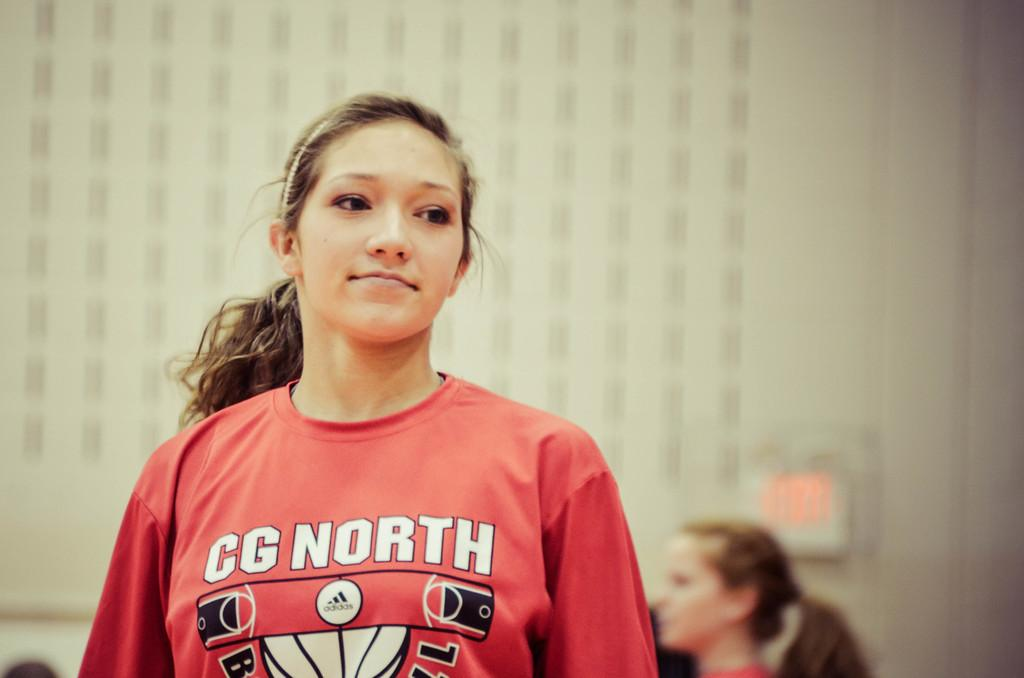<image>
Give a short and clear explanation of the subsequent image. A girl wearing a red shirt that has the text CG north and a adidas logo on it. 